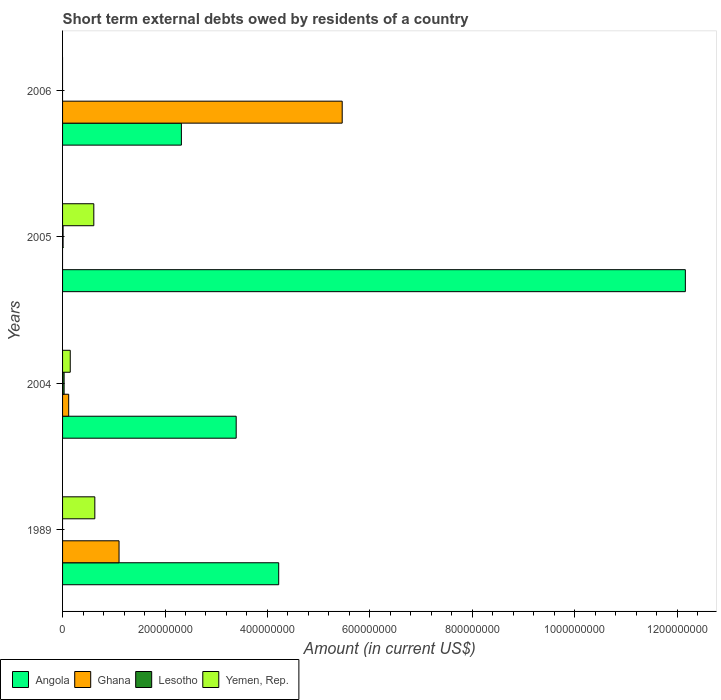How many different coloured bars are there?
Provide a short and direct response. 4. How many bars are there on the 2nd tick from the top?
Provide a short and direct response. 3. In how many cases, is the number of bars for a given year not equal to the number of legend labels?
Give a very brief answer. 3. What is the amount of short-term external debts owed by residents in Lesotho in 2006?
Make the answer very short. 0. Across all years, what is the maximum amount of short-term external debts owed by residents in Yemen, Rep.?
Your response must be concise. 6.30e+07. What is the total amount of short-term external debts owed by residents in Angola in the graph?
Your response must be concise. 2.21e+09. What is the difference between the amount of short-term external debts owed by residents in Angola in 2005 and that in 2006?
Offer a very short reply. 9.84e+08. What is the difference between the amount of short-term external debts owed by residents in Angola in 2004 and the amount of short-term external debts owed by residents in Lesotho in 2006?
Give a very brief answer. 3.39e+08. In the year 2004, what is the difference between the amount of short-term external debts owed by residents in Angola and amount of short-term external debts owed by residents in Lesotho?
Your response must be concise. 3.36e+08. In how many years, is the amount of short-term external debts owed by residents in Ghana greater than 960000000 US$?
Give a very brief answer. 0. What is the ratio of the amount of short-term external debts owed by residents in Ghana in 1989 to that in 2006?
Provide a succinct answer. 0.2. Is the difference between the amount of short-term external debts owed by residents in Angola in 2004 and 2005 greater than the difference between the amount of short-term external debts owed by residents in Lesotho in 2004 and 2005?
Give a very brief answer. No. What is the difference between the highest and the second highest amount of short-term external debts owed by residents in Angola?
Offer a very short reply. 7.94e+08. What is the difference between the highest and the lowest amount of short-term external debts owed by residents in Ghana?
Offer a terse response. 5.46e+08. In how many years, is the amount of short-term external debts owed by residents in Angola greater than the average amount of short-term external debts owed by residents in Angola taken over all years?
Offer a terse response. 1. Is it the case that in every year, the sum of the amount of short-term external debts owed by residents in Angola and amount of short-term external debts owed by residents in Yemen, Rep. is greater than the amount of short-term external debts owed by residents in Ghana?
Your answer should be very brief. No. How many bars are there?
Make the answer very short. 12. How many years are there in the graph?
Your response must be concise. 4. Are the values on the major ticks of X-axis written in scientific E-notation?
Make the answer very short. No. How many legend labels are there?
Make the answer very short. 4. What is the title of the graph?
Your answer should be compact. Short term external debts owed by residents of a country. What is the label or title of the Y-axis?
Make the answer very short. Years. What is the Amount (in current US$) in Angola in 1989?
Provide a short and direct response. 4.22e+08. What is the Amount (in current US$) of Ghana in 1989?
Your answer should be compact. 1.10e+08. What is the Amount (in current US$) in Lesotho in 1989?
Provide a succinct answer. 0. What is the Amount (in current US$) in Yemen, Rep. in 1989?
Keep it short and to the point. 6.30e+07. What is the Amount (in current US$) in Angola in 2004?
Provide a short and direct response. 3.39e+08. What is the Amount (in current US$) in Ghana in 2004?
Your answer should be very brief. 1.20e+07. What is the Amount (in current US$) of Yemen, Rep. in 2004?
Your answer should be very brief. 1.50e+07. What is the Amount (in current US$) of Angola in 2005?
Offer a terse response. 1.22e+09. What is the Amount (in current US$) in Ghana in 2005?
Provide a short and direct response. 0. What is the Amount (in current US$) in Yemen, Rep. in 2005?
Make the answer very short. 6.10e+07. What is the Amount (in current US$) in Angola in 2006?
Offer a terse response. 2.32e+08. What is the Amount (in current US$) of Ghana in 2006?
Provide a short and direct response. 5.46e+08. Across all years, what is the maximum Amount (in current US$) in Angola?
Give a very brief answer. 1.22e+09. Across all years, what is the maximum Amount (in current US$) of Ghana?
Your response must be concise. 5.46e+08. Across all years, what is the maximum Amount (in current US$) in Yemen, Rep.?
Make the answer very short. 6.30e+07. Across all years, what is the minimum Amount (in current US$) in Angola?
Ensure brevity in your answer.  2.32e+08. Across all years, what is the minimum Amount (in current US$) of Yemen, Rep.?
Make the answer very short. 0. What is the total Amount (in current US$) of Angola in the graph?
Keep it short and to the point. 2.21e+09. What is the total Amount (in current US$) of Ghana in the graph?
Make the answer very short. 6.68e+08. What is the total Amount (in current US$) of Yemen, Rep. in the graph?
Offer a very short reply. 1.39e+08. What is the difference between the Amount (in current US$) of Angola in 1989 and that in 2004?
Give a very brief answer. 8.30e+07. What is the difference between the Amount (in current US$) of Ghana in 1989 and that in 2004?
Provide a succinct answer. 9.83e+07. What is the difference between the Amount (in current US$) in Yemen, Rep. in 1989 and that in 2004?
Make the answer very short. 4.80e+07. What is the difference between the Amount (in current US$) of Angola in 1989 and that in 2005?
Your response must be concise. -7.94e+08. What is the difference between the Amount (in current US$) in Angola in 1989 and that in 2006?
Ensure brevity in your answer.  1.90e+08. What is the difference between the Amount (in current US$) in Ghana in 1989 and that in 2006?
Offer a terse response. -4.36e+08. What is the difference between the Amount (in current US$) in Angola in 2004 and that in 2005?
Give a very brief answer. -8.77e+08. What is the difference between the Amount (in current US$) of Yemen, Rep. in 2004 and that in 2005?
Give a very brief answer. -4.60e+07. What is the difference between the Amount (in current US$) in Angola in 2004 and that in 2006?
Your response must be concise. 1.07e+08. What is the difference between the Amount (in current US$) of Ghana in 2004 and that in 2006?
Your answer should be compact. -5.34e+08. What is the difference between the Amount (in current US$) of Angola in 2005 and that in 2006?
Give a very brief answer. 9.84e+08. What is the difference between the Amount (in current US$) of Angola in 1989 and the Amount (in current US$) of Ghana in 2004?
Give a very brief answer. 4.10e+08. What is the difference between the Amount (in current US$) of Angola in 1989 and the Amount (in current US$) of Lesotho in 2004?
Your answer should be compact. 4.19e+08. What is the difference between the Amount (in current US$) in Angola in 1989 and the Amount (in current US$) in Yemen, Rep. in 2004?
Make the answer very short. 4.07e+08. What is the difference between the Amount (in current US$) in Ghana in 1989 and the Amount (in current US$) in Lesotho in 2004?
Provide a short and direct response. 1.07e+08. What is the difference between the Amount (in current US$) in Ghana in 1989 and the Amount (in current US$) in Yemen, Rep. in 2004?
Ensure brevity in your answer.  9.53e+07. What is the difference between the Amount (in current US$) of Angola in 1989 and the Amount (in current US$) of Lesotho in 2005?
Make the answer very short. 4.21e+08. What is the difference between the Amount (in current US$) in Angola in 1989 and the Amount (in current US$) in Yemen, Rep. in 2005?
Your answer should be very brief. 3.61e+08. What is the difference between the Amount (in current US$) of Ghana in 1989 and the Amount (in current US$) of Lesotho in 2005?
Offer a terse response. 1.09e+08. What is the difference between the Amount (in current US$) in Ghana in 1989 and the Amount (in current US$) in Yemen, Rep. in 2005?
Offer a very short reply. 4.93e+07. What is the difference between the Amount (in current US$) in Angola in 1989 and the Amount (in current US$) in Ghana in 2006?
Make the answer very short. -1.24e+08. What is the difference between the Amount (in current US$) in Angola in 2004 and the Amount (in current US$) in Lesotho in 2005?
Offer a terse response. 3.38e+08. What is the difference between the Amount (in current US$) of Angola in 2004 and the Amount (in current US$) of Yemen, Rep. in 2005?
Keep it short and to the point. 2.78e+08. What is the difference between the Amount (in current US$) in Ghana in 2004 and the Amount (in current US$) in Lesotho in 2005?
Offer a terse response. 1.10e+07. What is the difference between the Amount (in current US$) in Ghana in 2004 and the Amount (in current US$) in Yemen, Rep. in 2005?
Offer a very short reply. -4.90e+07. What is the difference between the Amount (in current US$) of Lesotho in 2004 and the Amount (in current US$) of Yemen, Rep. in 2005?
Offer a terse response. -5.80e+07. What is the difference between the Amount (in current US$) of Angola in 2004 and the Amount (in current US$) of Ghana in 2006?
Provide a short and direct response. -2.07e+08. What is the difference between the Amount (in current US$) in Angola in 2005 and the Amount (in current US$) in Ghana in 2006?
Your answer should be very brief. 6.70e+08. What is the average Amount (in current US$) of Angola per year?
Give a very brief answer. 5.52e+08. What is the average Amount (in current US$) in Ghana per year?
Provide a short and direct response. 1.67e+08. What is the average Amount (in current US$) in Yemen, Rep. per year?
Provide a short and direct response. 3.48e+07. In the year 1989, what is the difference between the Amount (in current US$) in Angola and Amount (in current US$) in Ghana?
Provide a short and direct response. 3.12e+08. In the year 1989, what is the difference between the Amount (in current US$) of Angola and Amount (in current US$) of Yemen, Rep.?
Keep it short and to the point. 3.59e+08. In the year 1989, what is the difference between the Amount (in current US$) of Ghana and Amount (in current US$) of Yemen, Rep.?
Your answer should be very brief. 4.73e+07. In the year 2004, what is the difference between the Amount (in current US$) of Angola and Amount (in current US$) of Ghana?
Offer a terse response. 3.27e+08. In the year 2004, what is the difference between the Amount (in current US$) of Angola and Amount (in current US$) of Lesotho?
Give a very brief answer. 3.36e+08. In the year 2004, what is the difference between the Amount (in current US$) of Angola and Amount (in current US$) of Yemen, Rep.?
Keep it short and to the point. 3.24e+08. In the year 2004, what is the difference between the Amount (in current US$) in Ghana and Amount (in current US$) in Lesotho?
Offer a terse response. 8.96e+06. In the year 2004, what is the difference between the Amount (in current US$) of Ghana and Amount (in current US$) of Yemen, Rep.?
Ensure brevity in your answer.  -3.04e+06. In the year 2004, what is the difference between the Amount (in current US$) in Lesotho and Amount (in current US$) in Yemen, Rep.?
Make the answer very short. -1.20e+07. In the year 2005, what is the difference between the Amount (in current US$) in Angola and Amount (in current US$) in Lesotho?
Your response must be concise. 1.22e+09. In the year 2005, what is the difference between the Amount (in current US$) in Angola and Amount (in current US$) in Yemen, Rep.?
Make the answer very short. 1.16e+09. In the year 2005, what is the difference between the Amount (in current US$) of Lesotho and Amount (in current US$) of Yemen, Rep.?
Offer a terse response. -6.00e+07. In the year 2006, what is the difference between the Amount (in current US$) in Angola and Amount (in current US$) in Ghana?
Ensure brevity in your answer.  -3.14e+08. What is the ratio of the Amount (in current US$) of Angola in 1989 to that in 2004?
Offer a terse response. 1.24. What is the ratio of the Amount (in current US$) of Ghana in 1989 to that in 2004?
Offer a very short reply. 9.22. What is the ratio of the Amount (in current US$) of Yemen, Rep. in 1989 to that in 2004?
Your answer should be compact. 4.2. What is the ratio of the Amount (in current US$) of Angola in 1989 to that in 2005?
Provide a short and direct response. 0.35. What is the ratio of the Amount (in current US$) of Yemen, Rep. in 1989 to that in 2005?
Ensure brevity in your answer.  1.03. What is the ratio of the Amount (in current US$) in Angola in 1989 to that in 2006?
Your answer should be very brief. 1.82. What is the ratio of the Amount (in current US$) of Ghana in 1989 to that in 2006?
Make the answer very short. 0.2. What is the ratio of the Amount (in current US$) in Angola in 2004 to that in 2005?
Your answer should be compact. 0.28. What is the ratio of the Amount (in current US$) in Yemen, Rep. in 2004 to that in 2005?
Provide a short and direct response. 0.25. What is the ratio of the Amount (in current US$) of Angola in 2004 to that in 2006?
Your answer should be very brief. 1.46. What is the ratio of the Amount (in current US$) in Ghana in 2004 to that in 2006?
Make the answer very short. 0.02. What is the ratio of the Amount (in current US$) in Angola in 2005 to that in 2006?
Give a very brief answer. 5.24. What is the difference between the highest and the second highest Amount (in current US$) in Angola?
Offer a very short reply. 7.94e+08. What is the difference between the highest and the second highest Amount (in current US$) of Ghana?
Keep it short and to the point. 4.36e+08. What is the difference between the highest and the lowest Amount (in current US$) of Angola?
Make the answer very short. 9.84e+08. What is the difference between the highest and the lowest Amount (in current US$) in Ghana?
Make the answer very short. 5.46e+08. What is the difference between the highest and the lowest Amount (in current US$) of Lesotho?
Provide a succinct answer. 3.00e+06. What is the difference between the highest and the lowest Amount (in current US$) of Yemen, Rep.?
Ensure brevity in your answer.  6.30e+07. 